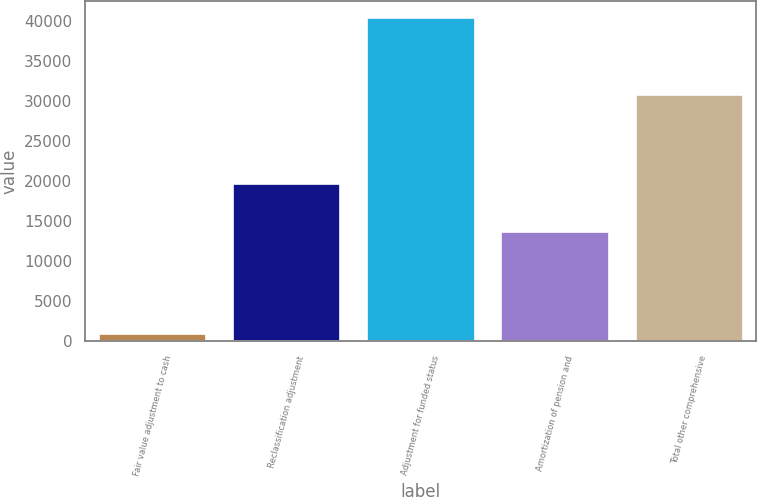Convert chart. <chart><loc_0><loc_0><loc_500><loc_500><bar_chart><fcel>Fair value adjustment to cash<fcel>Reclassification adjustment<fcel>Adjustment for funded status<fcel>Amortization of pension and<fcel>Total other comprehensive<nl><fcel>882<fcel>19619<fcel>40414<fcel>13589.4<fcel>30791<nl></chart> 